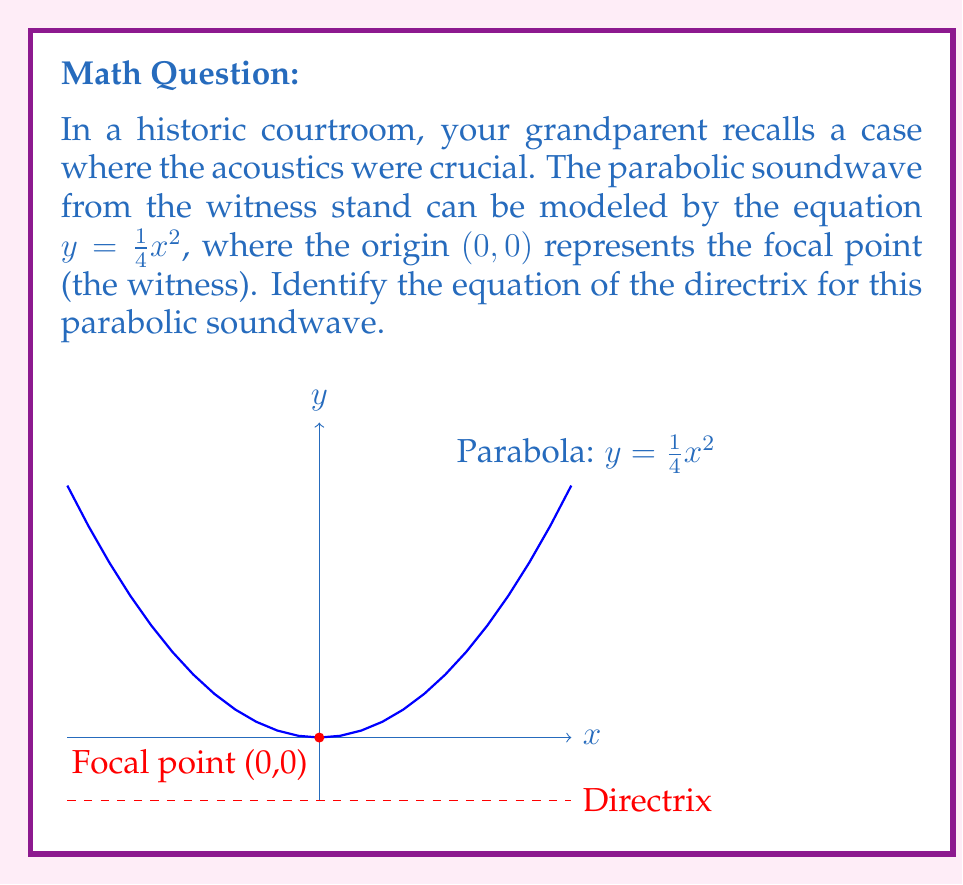Can you answer this question? To find the directrix of a parabola, we can follow these steps:

1) The general form of a parabola with vertex at $(0,0)$ is:

   $y = ax^2$

   In our case, $a = \frac{1}{4}$

2) For a parabola in this form, the focal length (distance from vertex to focus) is given by:

   $p = \frac{1}{4a}$

3) Substituting our value of $a$:

   $p = \frac{1}{4(\frac{1}{4})} = 1$

4) The directrix of a parabola is always at a distance of $p$ from the vertex, on the opposite side of the focus.

5) Since the focus is at $(0,0)$, which is also the vertex in this case, and the parabola opens upward, the directrix will be below the vertex at a distance of 1 unit.

6) Therefore, the equation of the directrix is:

   $y = -1$

This represents a horizontal line 1 unit below the x-axis.
Answer: $y = -1$ 